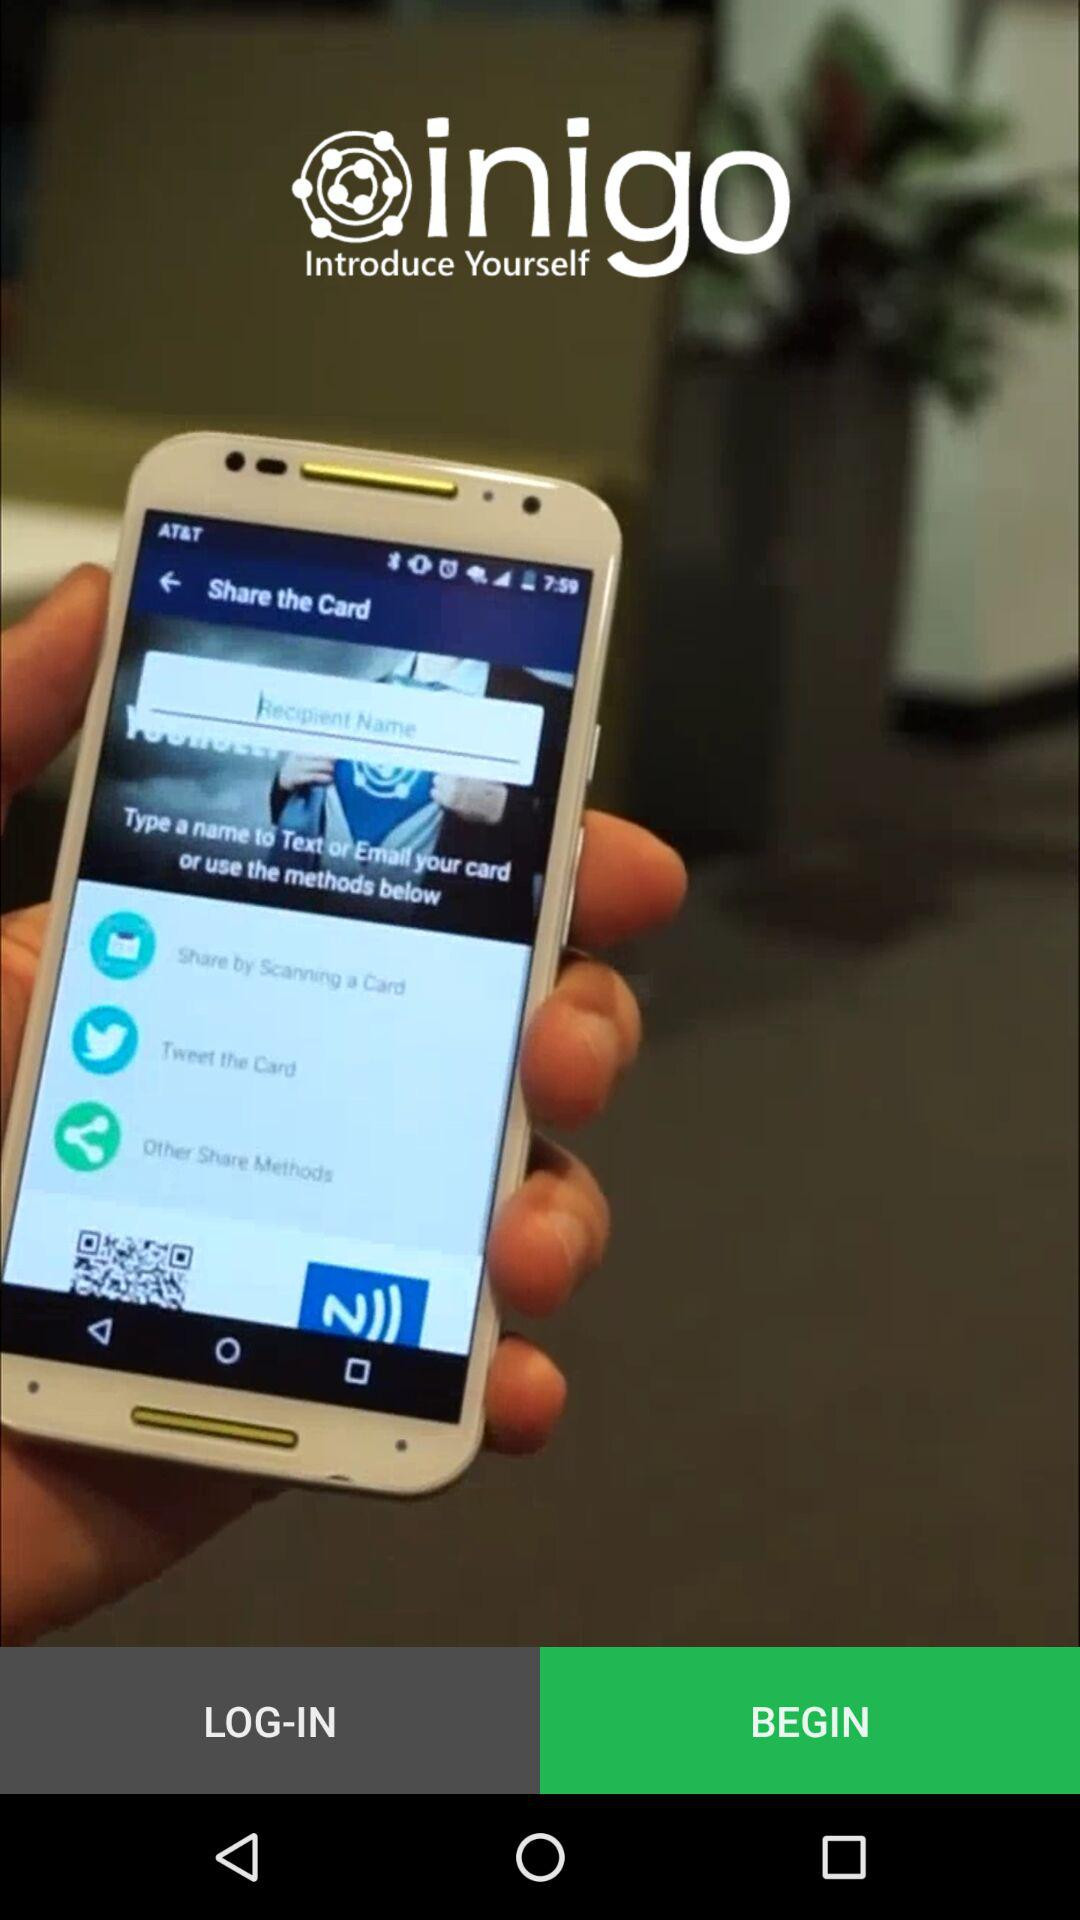What options are available for sharing the card shown in the image? The image shows multiple options for sharing the card including: scanning a card, sharing by Twitter, WhatsApp, and other methods indicated by a QR code and an NFC icon. 